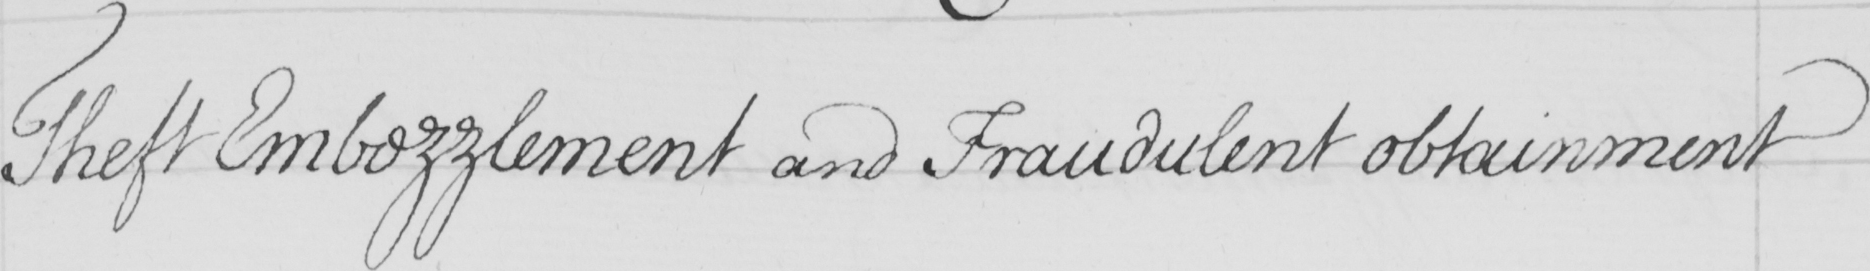What text is written in this handwritten line? Theft Embezzlement and Fraudulent obtainment 